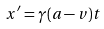<formula> <loc_0><loc_0><loc_500><loc_500>x ^ { \prime } = \gamma ( a - v ) t</formula> 